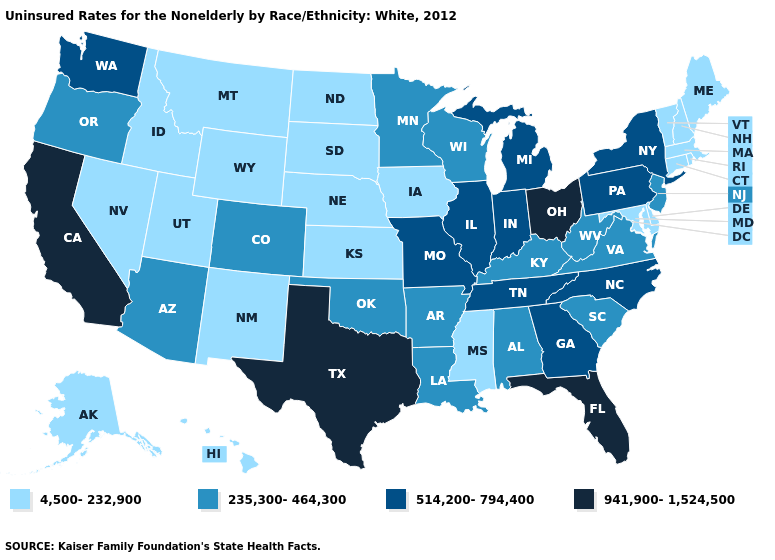What is the value of Oregon?
Concise answer only. 235,300-464,300. What is the value of Rhode Island?
Concise answer only. 4,500-232,900. Is the legend a continuous bar?
Short answer required. No. Among the states that border Virginia , which have the highest value?
Quick response, please. North Carolina, Tennessee. Name the states that have a value in the range 941,900-1,524,500?
Quick response, please. California, Florida, Ohio, Texas. What is the value of New York?
Answer briefly. 514,200-794,400. Name the states that have a value in the range 4,500-232,900?
Write a very short answer. Alaska, Connecticut, Delaware, Hawaii, Idaho, Iowa, Kansas, Maine, Maryland, Massachusetts, Mississippi, Montana, Nebraska, Nevada, New Hampshire, New Mexico, North Dakota, Rhode Island, South Dakota, Utah, Vermont, Wyoming. What is the value of Oklahoma?
Quick response, please. 235,300-464,300. Name the states that have a value in the range 235,300-464,300?
Give a very brief answer. Alabama, Arizona, Arkansas, Colorado, Kentucky, Louisiana, Minnesota, New Jersey, Oklahoma, Oregon, South Carolina, Virginia, West Virginia, Wisconsin. What is the highest value in the MidWest ?
Concise answer only. 941,900-1,524,500. How many symbols are there in the legend?
Short answer required. 4. Is the legend a continuous bar?
Quick response, please. No. Does Arizona have a lower value than North Dakota?
Give a very brief answer. No. Does Connecticut have the lowest value in the USA?
Quick response, please. Yes. What is the value of Pennsylvania?
Keep it brief. 514,200-794,400. 